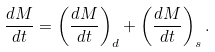<formula> <loc_0><loc_0><loc_500><loc_500>\frac { d M } { d t } = \left ( \frac { d M } { d t } \right ) _ { d } + \left ( \frac { d M } { d t } \right ) _ { s } .</formula> 